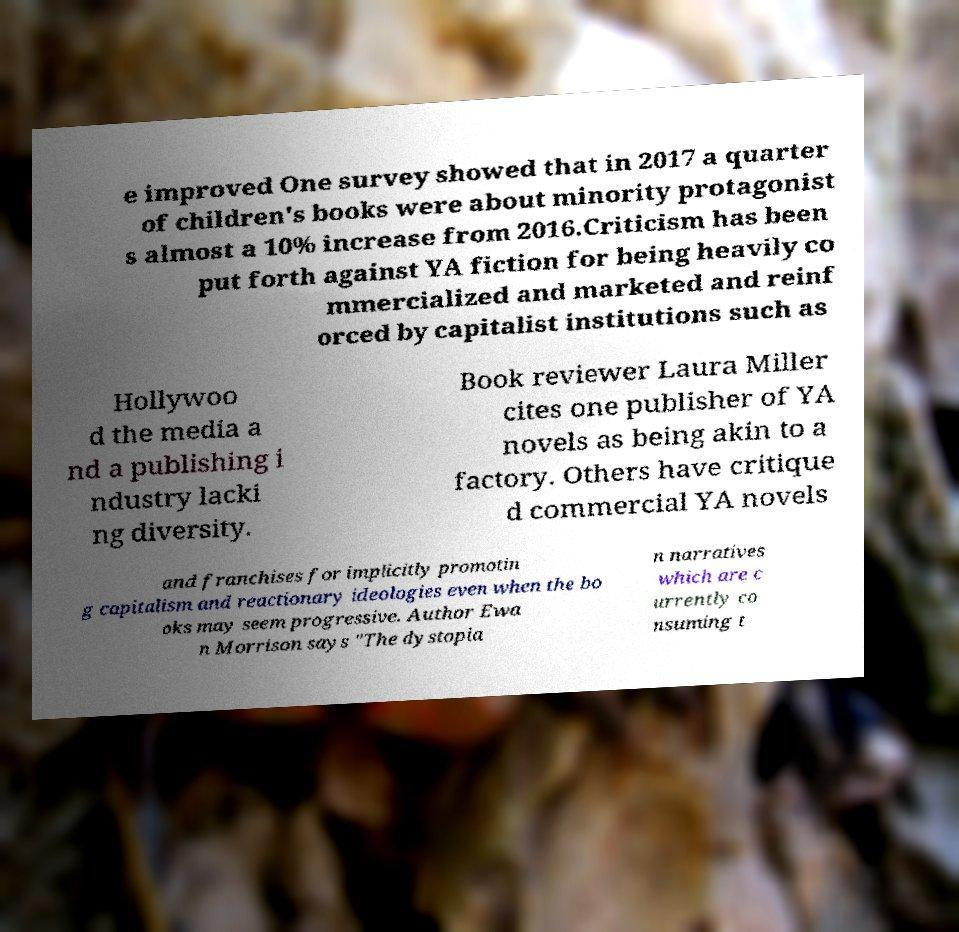Can you read and provide the text displayed in the image?This photo seems to have some interesting text. Can you extract and type it out for me? e improved One survey showed that in 2017 a quarter of children's books were about minority protagonist s almost a 10% increase from 2016.Criticism has been put forth against YA fiction for being heavily co mmercialized and marketed and reinf orced by capitalist institutions such as Hollywoo d the media a nd a publishing i ndustry lacki ng diversity. Book reviewer Laura Miller cites one publisher of YA novels as being akin to a factory. Others have critique d commercial YA novels and franchises for implicitly promotin g capitalism and reactionary ideologies even when the bo oks may seem progressive. Author Ewa n Morrison says "The dystopia n narratives which are c urrently co nsuming t 